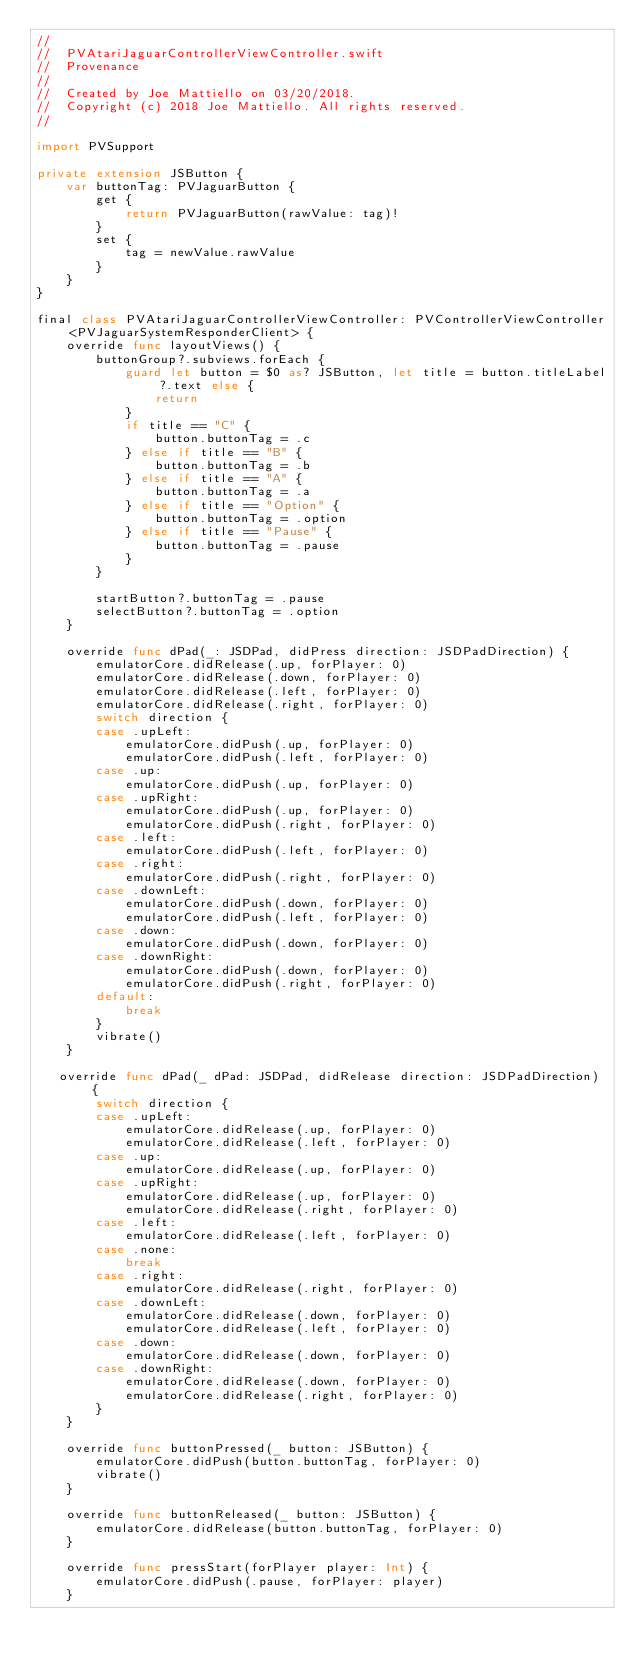Convert code to text. <code><loc_0><loc_0><loc_500><loc_500><_Swift_>//
//  PVAtariJaguarControllerViewController.swift
//  Provenance
//
//  Created by Joe Mattiello on 03/20/2018.
//  Copyright (c) 2018 Joe Mattiello. All rights reserved.
//

import PVSupport

private extension JSButton {
    var buttonTag: PVJaguarButton {
        get {
            return PVJaguarButton(rawValue: tag)!
        }
        set {
            tag = newValue.rawValue
        }
    }
}

final class PVAtariJaguarControllerViewController: PVControllerViewController<PVJaguarSystemResponderClient> {
    override func layoutViews() {
        buttonGroup?.subviews.forEach {
            guard let button = $0 as? JSButton, let title = button.titleLabel?.text else {
                return
            }
            if title == "C" {
                button.buttonTag = .c
            } else if title == "B" {
                button.buttonTag = .b
            } else if title == "A" {
                button.buttonTag = .a
            } else if title == "Option" {
                button.buttonTag = .option
            } else if title == "Pause" {
                button.buttonTag = .pause
            }
        }

        startButton?.buttonTag = .pause
        selectButton?.buttonTag = .option
    }

    override func dPad(_: JSDPad, didPress direction: JSDPadDirection) {
        emulatorCore.didRelease(.up, forPlayer: 0)
        emulatorCore.didRelease(.down, forPlayer: 0)
        emulatorCore.didRelease(.left, forPlayer: 0)
        emulatorCore.didRelease(.right, forPlayer: 0)
        switch direction {
        case .upLeft:
            emulatorCore.didPush(.up, forPlayer: 0)
            emulatorCore.didPush(.left, forPlayer: 0)
        case .up:
            emulatorCore.didPush(.up, forPlayer: 0)
        case .upRight:
            emulatorCore.didPush(.up, forPlayer: 0)
            emulatorCore.didPush(.right, forPlayer: 0)
        case .left:
            emulatorCore.didPush(.left, forPlayer: 0)
        case .right:
            emulatorCore.didPush(.right, forPlayer: 0)
        case .downLeft:
            emulatorCore.didPush(.down, forPlayer: 0)
            emulatorCore.didPush(.left, forPlayer: 0)
        case .down:
            emulatorCore.didPush(.down, forPlayer: 0)
        case .downRight:
            emulatorCore.didPush(.down, forPlayer: 0)
            emulatorCore.didPush(.right, forPlayer: 0)
        default:
            break
        }
        vibrate()
    }

   override func dPad(_ dPad: JSDPad, didRelease direction: JSDPadDirection) {
        switch direction {
        case .upLeft:
            emulatorCore.didRelease(.up, forPlayer: 0)
            emulatorCore.didRelease(.left, forPlayer: 0)
        case .up:
            emulatorCore.didRelease(.up, forPlayer: 0)
        case .upRight:
            emulatorCore.didRelease(.up, forPlayer: 0)
            emulatorCore.didRelease(.right, forPlayer: 0)
        case .left:
            emulatorCore.didRelease(.left, forPlayer: 0)
        case .none:
            break
        case .right:
            emulatorCore.didRelease(.right, forPlayer: 0)
        case .downLeft:
            emulatorCore.didRelease(.down, forPlayer: 0)
            emulatorCore.didRelease(.left, forPlayer: 0)
        case .down:
            emulatorCore.didRelease(.down, forPlayer: 0)
        case .downRight:
            emulatorCore.didRelease(.down, forPlayer: 0)
            emulatorCore.didRelease(.right, forPlayer: 0)
        }
    }

    override func buttonPressed(_ button: JSButton) {
        emulatorCore.didPush(button.buttonTag, forPlayer: 0)
        vibrate()
    }

    override func buttonReleased(_ button: JSButton) {
        emulatorCore.didRelease(button.buttonTag, forPlayer: 0)
    }

    override func pressStart(forPlayer player: Int) {
        emulatorCore.didPush(.pause, forPlayer: player)
    }
</code> 